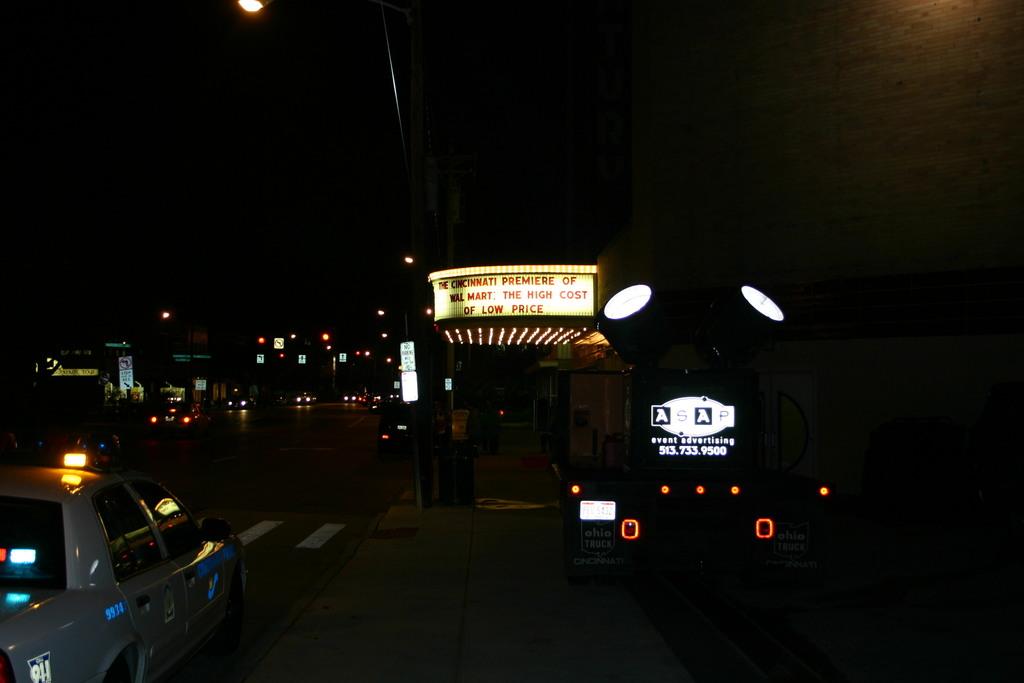What city is this?
Make the answer very short. Cincinnati. What are they premiering?
Make the answer very short. Walmart: the high cost of low price. 